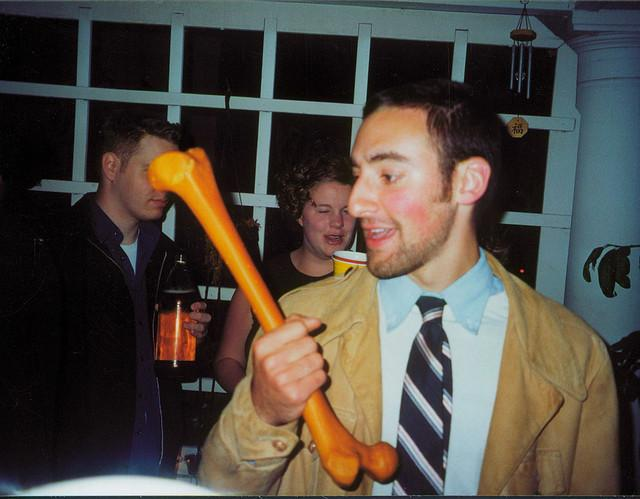What is the orange object called?

Choices:
A) bone
B) hammer
C) bat
D) sickle bone 